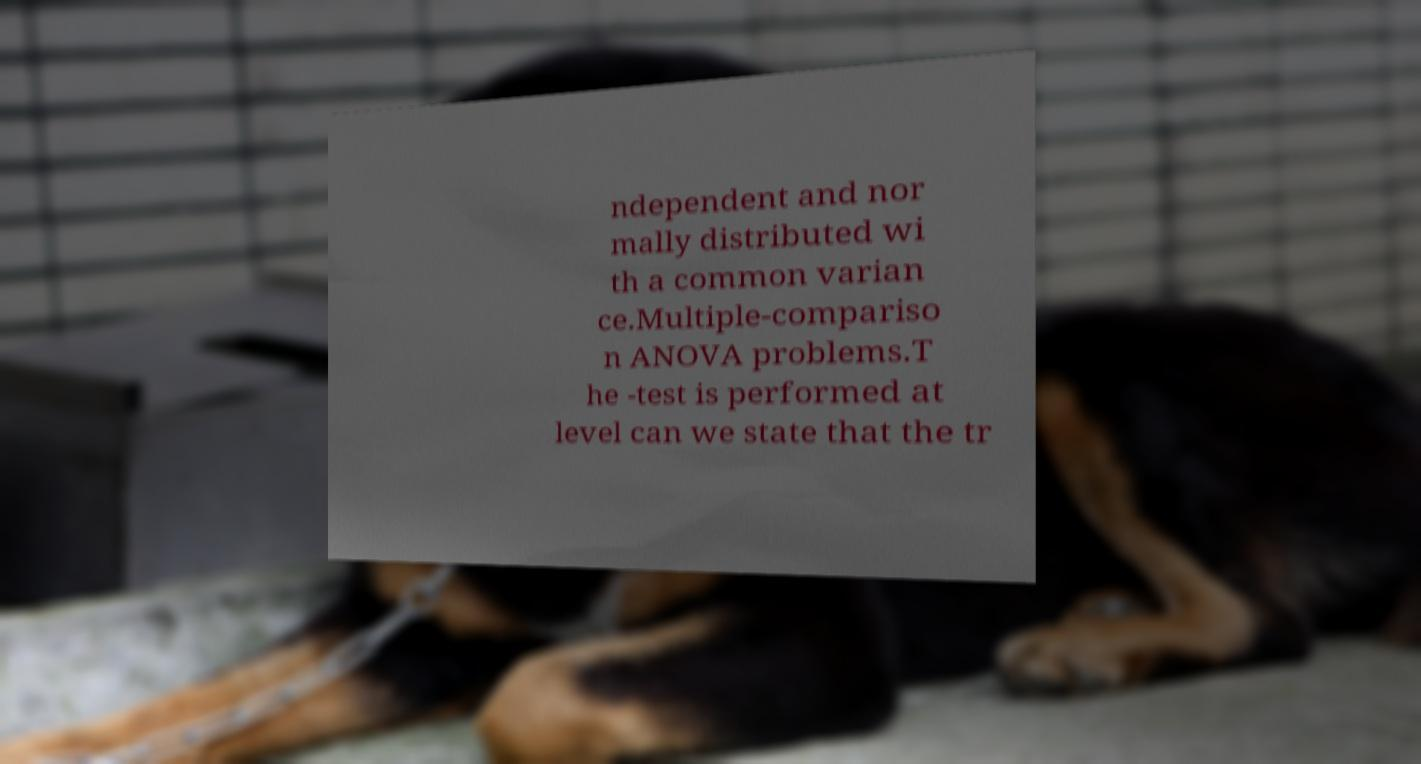Can you read and provide the text displayed in the image?This photo seems to have some interesting text. Can you extract and type it out for me? ndependent and nor mally distributed wi th a common varian ce.Multiple-compariso n ANOVA problems.T he -test is performed at level can we state that the tr 